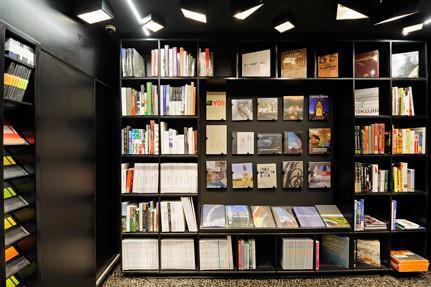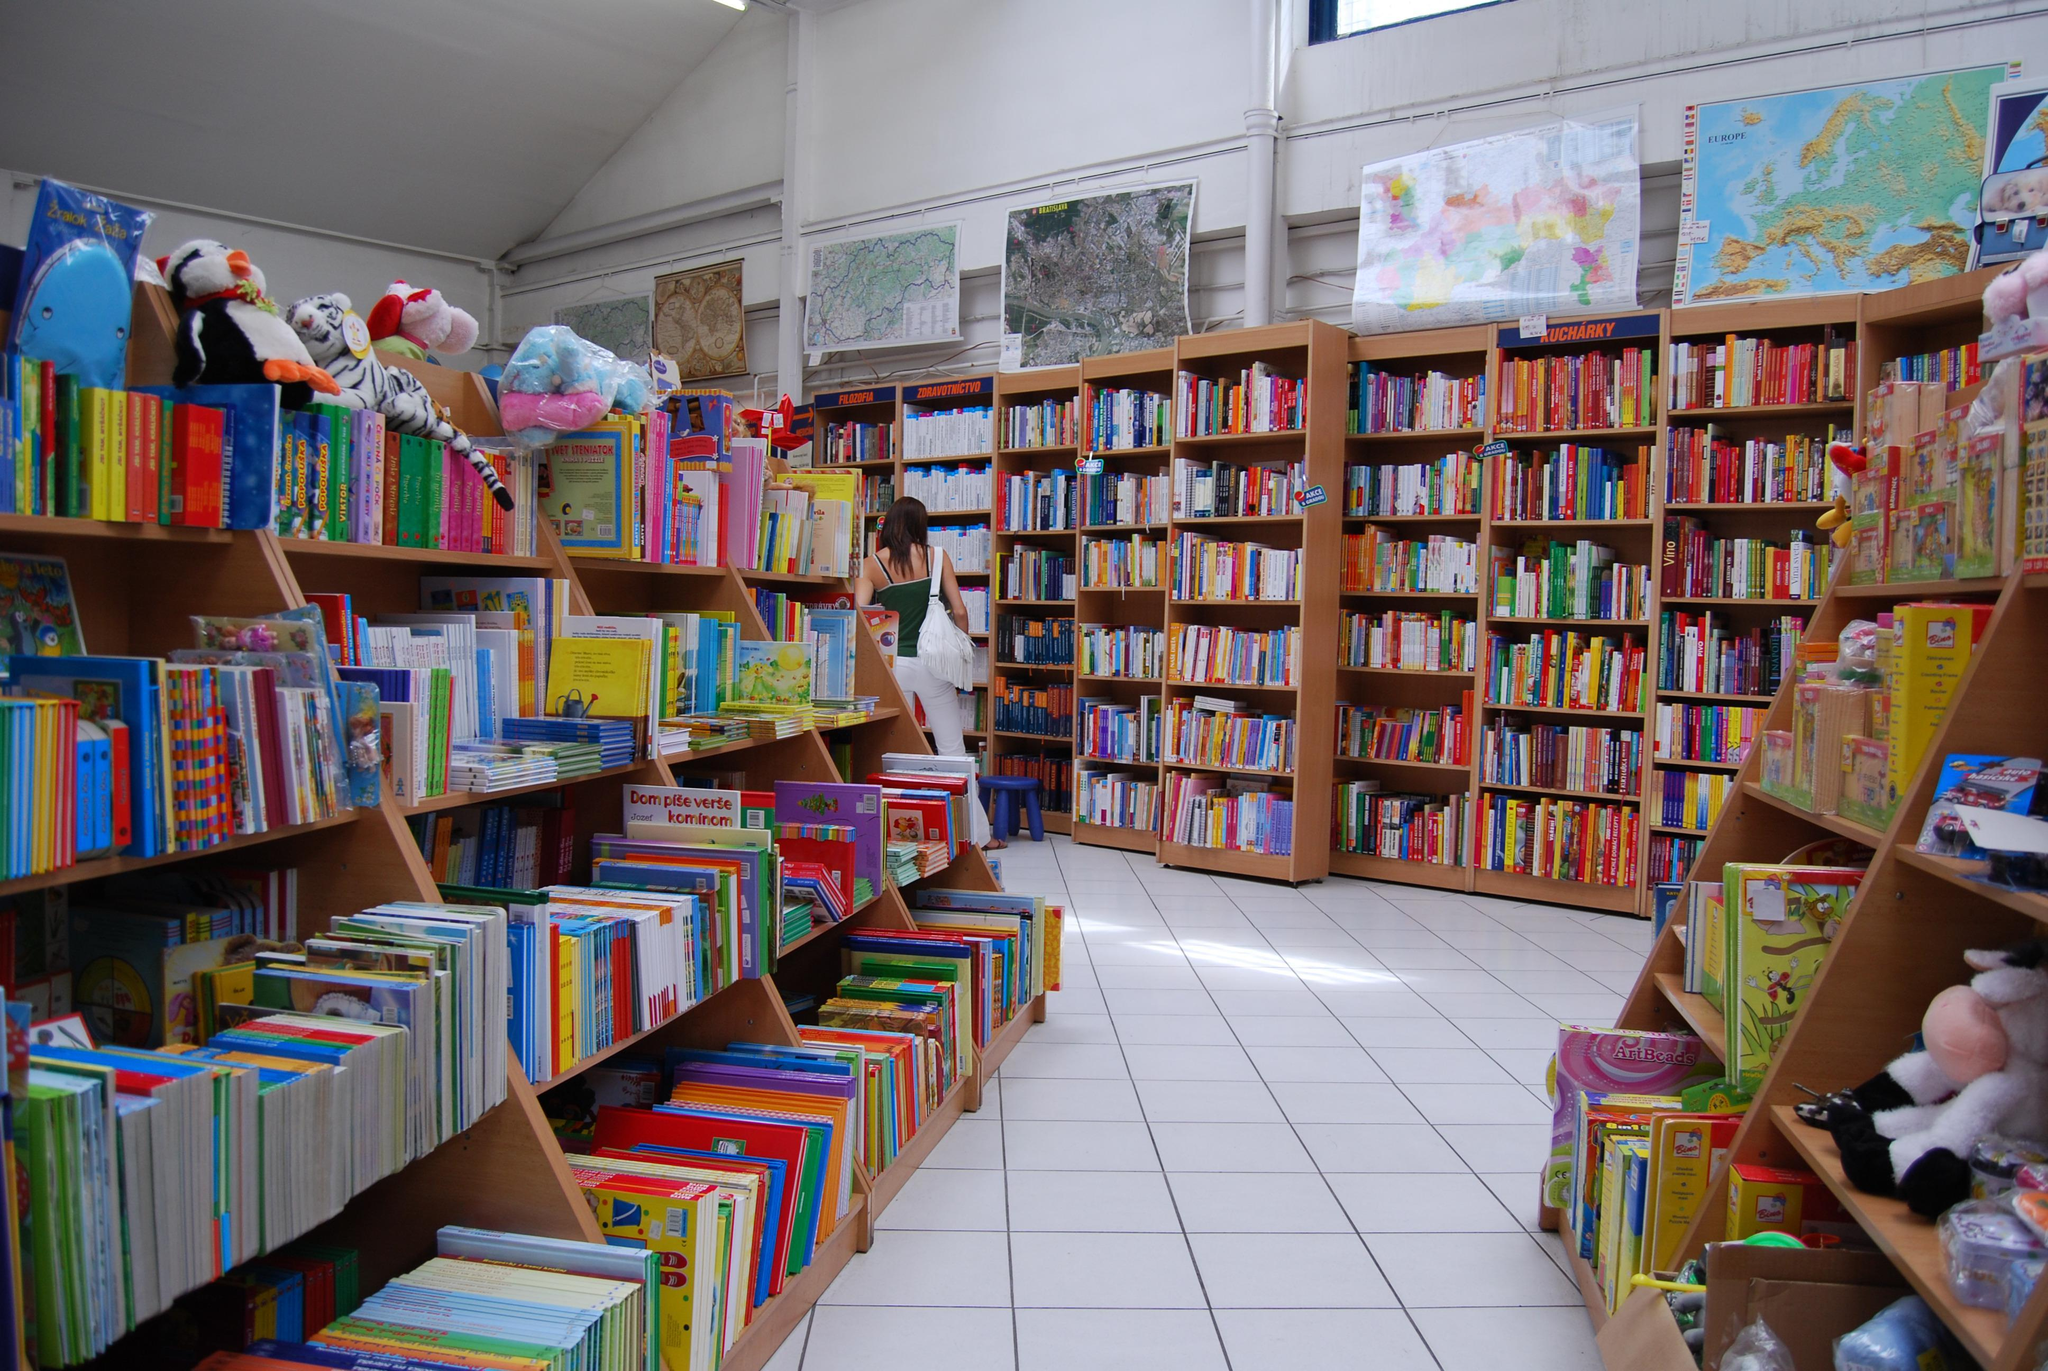The first image is the image on the left, the second image is the image on the right. Analyze the images presented: Is the assertion "There is seating visible in at least one of the images." valid? Answer yes or no. No. The first image is the image on the left, the second image is the image on the right. Given the left and right images, does the statement "Atleast one building has a wooden floor." hold true? Answer yes or no. No. 